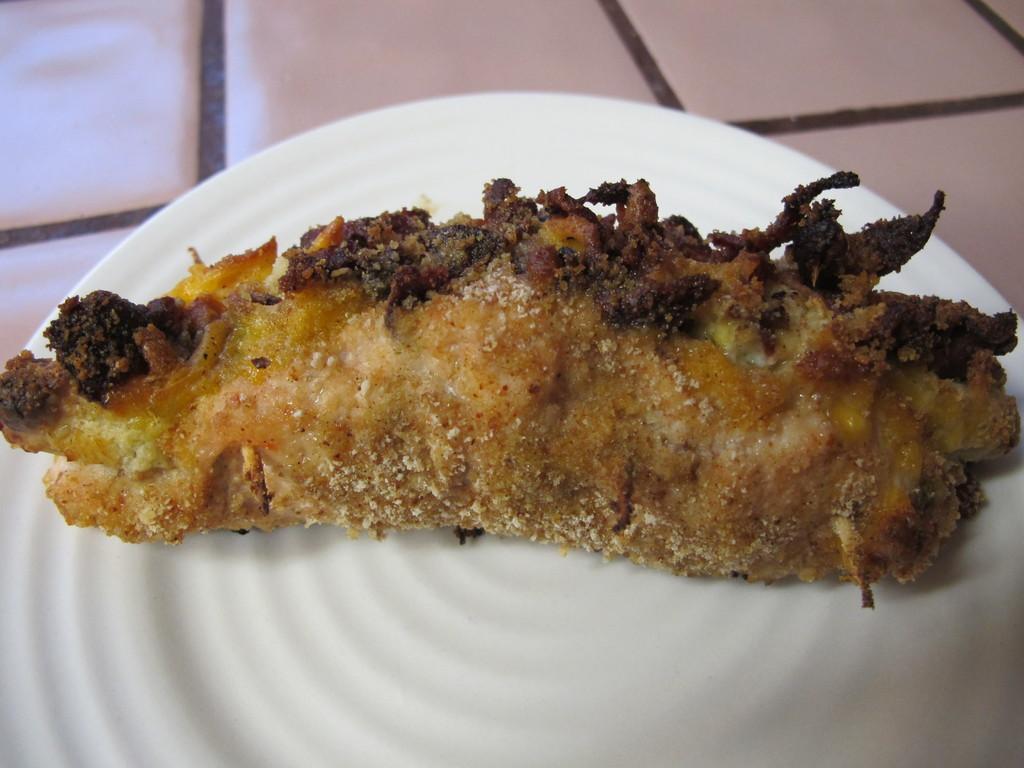Could you give a brief overview of what you see in this image? In this picture we can see a white plate with food on it and this plate is placed on a surface. 